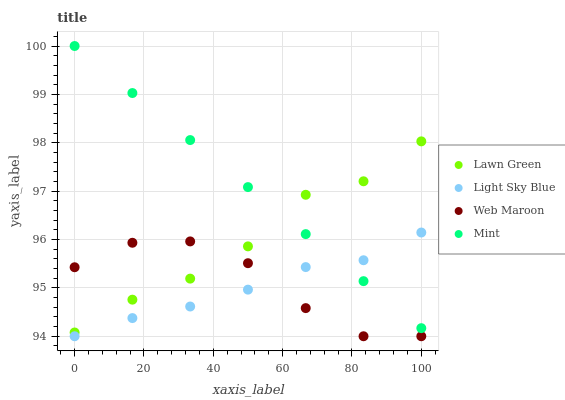Does Light Sky Blue have the minimum area under the curve?
Answer yes or no. Yes. Does Mint have the maximum area under the curve?
Answer yes or no. Yes. Does Web Maroon have the minimum area under the curve?
Answer yes or no. No. Does Web Maroon have the maximum area under the curve?
Answer yes or no. No. Is Mint the smoothest?
Answer yes or no. Yes. Is Web Maroon the roughest?
Answer yes or no. Yes. Is Light Sky Blue the smoothest?
Answer yes or no. No. Is Light Sky Blue the roughest?
Answer yes or no. No. Does Light Sky Blue have the lowest value?
Answer yes or no. Yes. Does Mint have the lowest value?
Answer yes or no. No. Does Mint have the highest value?
Answer yes or no. Yes. Does Light Sky Blue have the highest value?
Answer yes or no. No. Is Web Maroon less than Mint?
Answer yes or no. Yes. Is Lawn Green greater than Light Sky Blue?
Answer yes or no. Yes. Does Lawn Green intersect Web Maroon?
Answer yes or no. Yes. Is Lawn Green less than Web Maroon?
Answer yes or no. No. Is Lawn Green greater than Web Maroon?
Answer yes or no. No. Does Web Maroon intersect Mint?
Answer yes or no. No. 